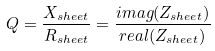Convert formula to latex. <formula><loc_0><loc_0><loc_500><loc_500>Q = \frac { X _ { s h e e t } } { R _ { s h e e t } } = \frac { i m a g ( Z _ { s h e e t } ) } { r e a l ( Z _ { s h e e t } ) }</formula> 